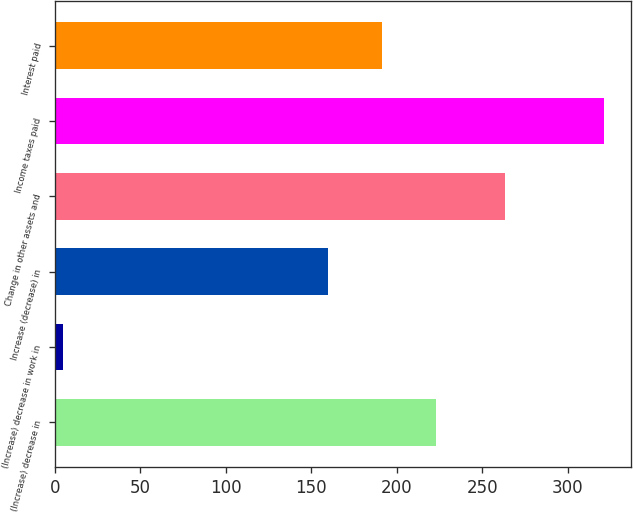Convert chart to OTSL. <chart><loc_0><loc_0><loc_500><loc_500><bar_chart><fcel>(Increase) decrease in<fcel>(Increase) decrease in work in<fcel>Increase (decrease) in<fcel>Change in other assets and<fcel>Income taxes paid<fcel>Interest paid<nl><fcel>222.69<fcel>4.8<fcel>159.43<fcel>263.1<fcel>321.1<fcel>191.06<nl></chart> 